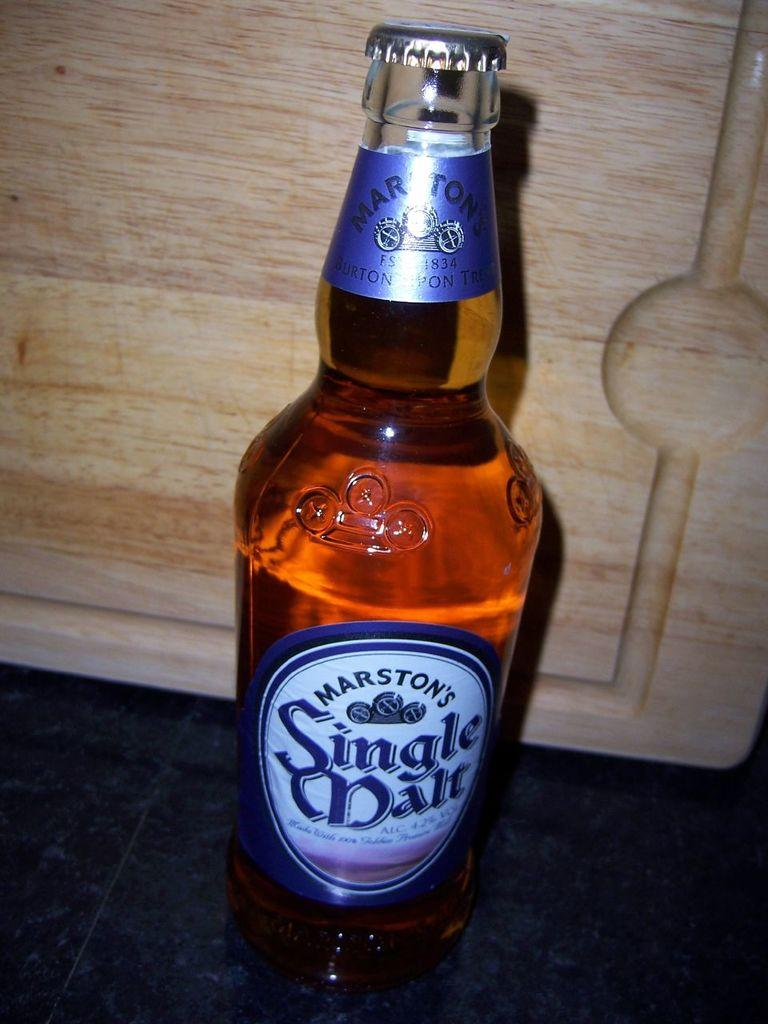<image>
Share a concise interpretation of the image provided. A glass of beer, marston's sangle mate, the cap is still on 